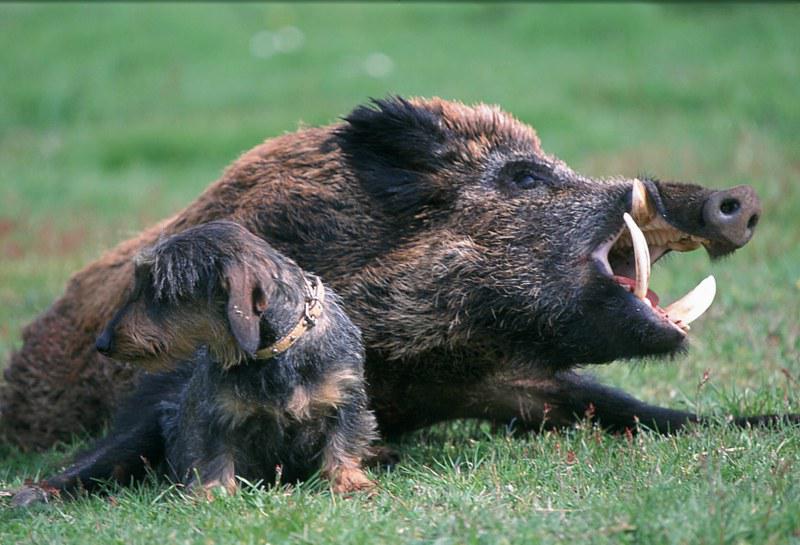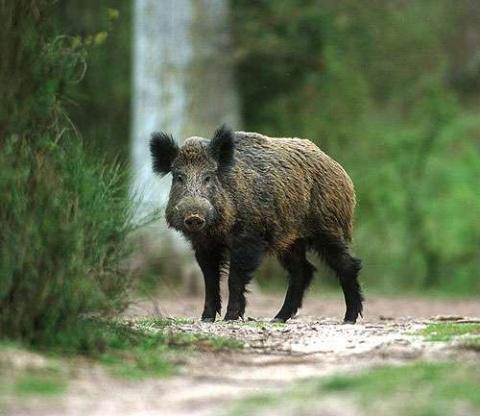The first image is the image on the left, the second image is the image on the right. Examine the images to the left and right. Is the description "In one of the images there is a man posing behind a large boar." accurate? Answer yes or no. No. The first image is the image on the left, the second image is the image on the right. Analyze the images presented: Is the assertion "An image shows a person posed behind a dead boar." valid? Answer yes or no. No. 